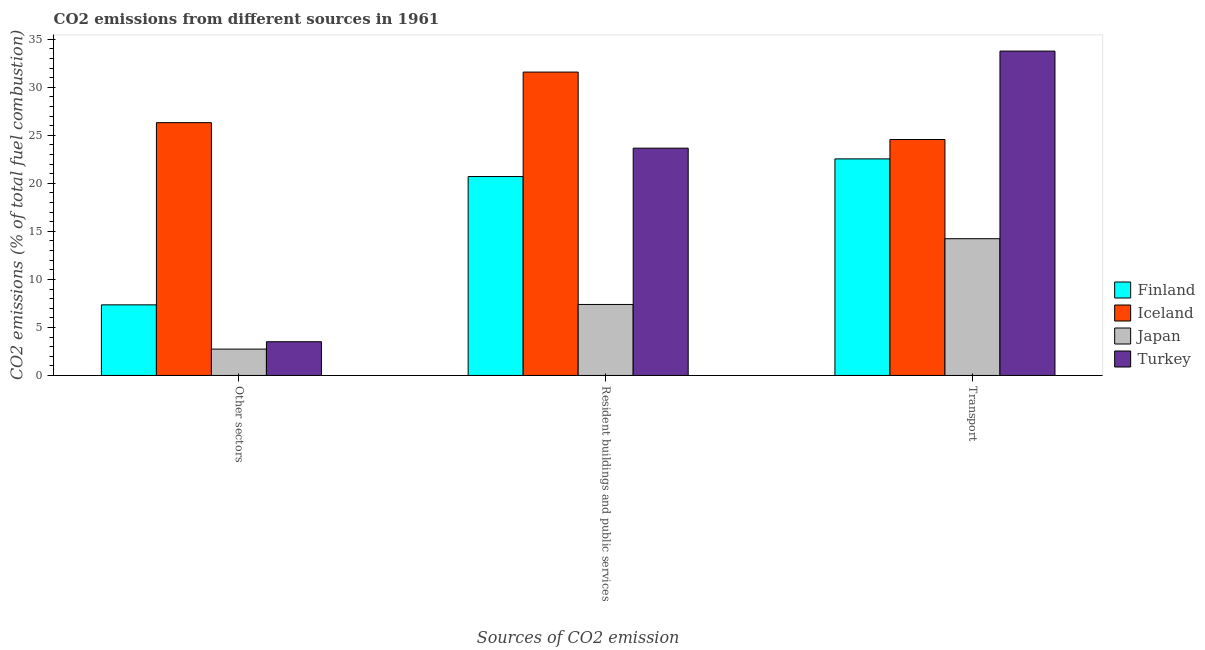How many different coloured bars are there?
Your answer should be very brief. 4. How many bars are there on the 1st tick from the left?
Ensure brevity in your answer.  4. What is the label of the 1st group of bars from the left?
Your answer should be very brief. Other sectors. What is the percentage of co2 emissions from resident buildings and public services in Iceland?
Your response must be concise. 31.58. Across all countries, what is the maximum percentage of co2 emissions from resident buildings and public services?
Keep it short and to the point. 31.58. Across all countries, what is the minimum percentage of co2 emissions from transport?
Your response must be concise. 14.23. In which country was the percentage of co2 emissions from transport minimum?
Keep it short and to the point. Japan. What is the total percentage of co2 emissions from resident buildings and public services in the graph?
Give a very brief answer. 83.34. What is the difference between the percentage of co2 emissions from other sectors in Finland and that in Japan?
Keep it short and to the point. 4.61. What is the difference between the percentage of co2 emissions from resident buildings and public services in Iceland and the percentage of co2 emissions from transport in Turkey?
Provide a short and direct response. -2.19. What is the average percentage of co2 emissions from transport per country?
Offer a terse response. 23.78. What is the difference between the percentage of co2 emissions from other sectors and percentage of co2 emissions from transport in Iceland?
Ensure brevity in your answer.  1.75. In how many countries, is the percentage of co2 emissions from other sectors greater than 20 %?
Provide a short and direct response. 1. What is the ratio of the percentage of co2 emissions from resident buildings and public services in Iceland to that in Japan?
Provide a short and direct response. 4.27. Is the percentage of co2 emissions from resident buildings and public services in Finland less than that in Turkey?
Your response must be concise. Yes. What is the difference between the highest and the second highest percentage of co2 emissions from transport?
Offer a very short reply. 9.2. What is the difference between the highest and the lowest percentage of co2 emissions from other sectors?
Your answer should be compact. 23.57. In how many countries, is the percentage of co2 emissions from resident buildings and public services greater than the average percentage of co2 emissions from resident buildings and public services taken over all countries?
Provide a short and direct response. 2. Is the sum of the percentage of co2 emissions from other sectors in Japan and Finland greater than the maximum percentage of co2 emissions from transport across all countries?
Offer a terse response. No. What does the 1st bar from the right in Transport represents?
Offer a very short reply. Turkey. How many bars are there?
Your answer should be compact. 12. Are all the bars in the graph horizontal?
Offer a terse response. No. Are the values on the major ticks of Y-axis written in scientific E-notation?
Your response must be concise. No. Does the graph contain any zero values?
Your answer should be very brief. No. How are the legend labels stacked?
Your response must be concise. Vertical. What is the title of the graph?
Your answer should be very brief. CO2 emissions from different sources in 1961. Does "El Salvador" appear as one of the legend labels in the graph?
Give a very brief answer. No. What is the label or title of the X-axis?
Make the answer very short. Sources of CO2 emission. What is the label or title of the Y-axis?
Make the answer very short. CO2 emissions (% of total fuel combustion). What is the CO2 emissions (% of total fuel combustion) in Finland in Other sectors?
Your response must be concise. 7.35. What is the CO2 emissions (% of total fuel combustion) in Iceland in Other sectors?
Offer a terse response. 26.32. What is the CO2 emissions (% of total fuel combustion) of Japan in Other sectors?
Make the answer very short. 2.74. What is the CO2 emissions (% of total fuel combustion) in Turkey in Other sectors?
Offer a very short reply. 3.51. What is the CO2 emissions (% of total fuel combustion) of Finland in Resident buildings and public services?
Offer a very short reply. 20.71. What is the CO2 emissions (% of total fuel combustion) in Iceland in Resident buildings and public services?
Your response must be concise. 31.58. What is the CO2 emissions (% of total fuel combustion) in Japan in Resident buildings and public services?
Ensure brevity in your answer.  7.39. What is the CO2 emissions (% of total fuel combustion) in Turkey in Resident buildings and public services?
Offer a terse response. 23.66. What is the CO2 emissions (% of total fuel combustion) of Finland in Transport?
Your answer should be very brief. 22.54. What is the CO2 emissions (% of total fuel combustion) of Iceland in Transport?
Ensure brevity in your answer.  24.56. What is the CO2 emissions (% of total fuel combustion) of Japan in Transport?
Keep it short and to the point. 14.23. What is the CO2 emissions (% of total fuel combustion) in Turkey in Transport?
Your answer should be very brief. 33.76. Across all Sources of CO2 emission, what is the maximum CO2 emissions (% of total fuel combustion) of Finland?
Ensure brevity in your answer.  22.54. Across all Sources of CO2 emission, what is the maximum CO2 emissions (% of total fuel combustion) of Iceland?
Offer a very short reply. 31.58. Across all Sources of CO2 emission, what is the maximum CO2 emissions (% of total fuel combustion) of Japan?
Provide a succinct answer. 14.23. Across all Sources of CO2 emission, what is the maximum CO2 emissions (% of total fuel combustion) of Turkey?
Make the answer very short. 33.76. Across all Sources of CO2 emission, what is the minimum CO2 emissions (% of total fuel combustion) in Finland?
Give a very brief answer. 7.35. Across all Sources of CO2 emission, what is the minimum CO2 emissions (% of total fuel combustion) of Iceland?
Ensure brevity in your answer.  24.56. Across all Sources of CO2 emission, what is the minimum CO2 emissions (% of total fuel combustion) of Japan?
Your response must be concise. 2.74. Across all Sources of CO2 emission, what is the minimum CO2 emissions (% of total fuel combustion) of Turkey?
Keep it short and to the point. 3.51. What is the total CO2 emissions (% of total fuel combustion) of Finland in the graph?
Offer a very short reply. 50.6. What is the total CO2 emissions (% of total fuel combustion) in Iceland in the graph?
Your response must be concise. 82.46. What is the total CO2 emissions (% of total fuel combustion) of Japan in the graph?
Make the answer very short. 24.37. What is the total CO2 emissions (% of total fuel combustion) in Turkey in the graph?
Give a very brief answer. 60.94. What is the difference between the CO2 emissions (% of total fuel combustion) in Finland in Other sectors and that in Resident buildings and public services?
Give a very brief answer. -13.36. What is the difference between the CO2 emissions (% of total fuel combustion) of Iceland in Other sectors and that in Resident buildings and public services?
Make the answer very short. -5.26. What is the difference between the CO2 emissions (% of total fuel combustion) of Japan in Other sectors and that in Resident buildings and public services?
Ensure brevity in your answer.  -4.65. What is the difference between the CO2 emissions (% of total fuel combustion) of Turkey in Other sectors and that in Resident buildings and public services?
Your response must be concise. -20.15. What is the difference between the CO2 emissions (% of total fuel combustion) of Finland in Other sectors and that in Transport?
Your response must be concise. -15.19. What is the difference between the CO2 emissions (% of total fuel combustion) of Iceland in Other sectors and that in Transport?
Offer a very short reply. 1.75. What is the difference between the CO2 emissions (% of total fuel combustion) in Japan in Other sectors and that in Transport?
Offer a very short reply. -11.49. What is the difference between the CO2 emissions (% of total fuel combustion) in Turkey in Other sectors and that in Transport?
Ensure brevity in your answer.  -30.25. What is the difference between the CO2 emissions (% of total fuel combustion) in Finland in Resident buildings and public services and that in Transport?
Your response must be concise. -1.84. What is the difference between the CO2 emissions (% of total fuel combustion) of Iceland in Resident buildings and public services and that in Transport?
Offer a very short reply. 7.02. What is the difference between the CO2 emissions (% of total fuel combustion) in Japan in Resident buildings and public services and that in Transport?
Keep it short and to the point. -6.84. What is the difference between the CO2 emissions (% of total fuel combustion) of Turkey in Resident buildings and public services and that in Transport?
Keep it short and to the point. -10.1. What is the difference between the CO2 emissions (% of total fuel combustion) of Finland in Other sectors and the CO2 emissions (% of total fuel combustion) of Iceland in Resident buildings and public services?
Your answer should be very brief. -24.23. What is the difference between the CO2 emissions (% of total fuel combustion) in Finland in Other sectors and the CO2 emissions (% of total fuel combustion) in Japan in Resident buildings and public services?
Keep it short and to the point. -0.04. What is the difference between the CO2 emissions (% of total fuel combustion) in Finland in Other sectors and the CO2 emissions (% of total fuel combustion) in Turkey in Resident buildings and public services?
Your answer should be very brief. -16.31. What is the difference between the CO2 emissions (% of total fuel combustion) of Iceland in Other sectors and the CO2 emissions (% of total fuel combustion) of Japan in Resident buildings and public services?
Your answer should be compact. 18.93. What is the difference between the CO2 emissions (% of total fuel combustion) in Iceland in Other sectors and the CO2 emissions (% of total fuel combustion) in Turkey in Resident buildings and public services?
Your response must be concise. 2.66. What is the difference between the CO2 emissions (% of total fuel combustion) in Japan in Other sectors and the CO2 emissions (% of total fuel combustion) in Turkey in Resident buildings and public services?
Keep it short and to the point. -20.92. What is the difference between the CO2 emissions (% of total fuel combustion) of Finland in Other sectors and the CO2 emissions (% of total fuel combustion) of Iceland in Transport?
Your response must be concise. -17.21. What is the difference between the CO2 emissions (% of total fuel combustion) of Finland in Other sectors and the CO2 emissions (% of total fuel combustion) of Japan in Transport?
Make the answer very short. -6.88. What is the difference between the CO2 emissions (% of total fuel combustion) in Finland in Other sectors and the CO2 emissions (% of total fuel combustion) in Turkey in Transport?
Provide a short and direct response. -26.41. What is the difference between the CO2 emissions (% of total fuel combustion) in Iceland in Other sectors and the CO2 emissions (% of total fuel combustion) in Japan in Transport?
Give a very brief answer. 12.08. What is the difference between the CO2 emissions (% of total fuel combustion) in Iceland in Other sectors and the CO2 emissions (% of total fuel combustion) in Turkey in Transport?
Ensure brevity in your answer.  -7.45. What is the difference between the CO2 emissions (% of total fuel combustion) in Japan in Other sectors and the CO2 emissions (% of total fuel combustion) in Turkey in Transport?
Give a very brief answer. -31.02. What is the difference between the CO2 emissions (% of total fuel combustion) in Finland in Resident buildings and public services and the CO2 emissions (% of total fuel combustion) in Iceland in Transport?
Offer a very short reply. -3.85. What is the difference between the CO2 emissions (% of total fuel combustion) in Finland in Resident buildings and public services and the CO2 emissions (% of total fuel combustion) in Japan in Transport?
Offer a very short reply. 6.47. What is the difference between the CO2 emissions (% of total fuel combustion) of Finland in Resident buildings and public services and the CO2 emissions (% of total fuel combustion) of Turkey in Transport?
Your answer should be very brief. -13.06. What is the difference between the CO2 emissions (% of total fuel combustion) of Iceland in Resident buildings and public services and the CO2 emissions (% of total fuel combustion) of Japan in Transport?
Keep it short and to the point. 17.34. What is the difference between the CO2 emissions (% of total fuel combustion) in Iceland in Resident buildings and public services and the CO2 emissions (% of total fuel combustion) in Turkey in Transport?
Your answer should be very brief. -2.19. What is the difference between the CO2 emissions (% of total fuel combustion) of Japan in Resident buildings and public services and the CO2 emissions (% of total fuel combustion) of Turkey in Transport?
Give a very brief answer. -26.37. What is the average CO2 emissions (% of total fuel combustion) in Finland per Sources of CO2 emission?
Your answer should be compact. 16.87. What is the average CO2 emissions (% of total fuel combustion) of Iceland per Sources of CO2 emission?
Ensure brevity in your answer.  27.49. What is the average CO2 emissions (% of total fuel combustion) of Japan per Sources of CO2 emission?
Keep it short and to the point. 8.12. What is the average CO2 emissions (% of total fuel combustion) in Turkey per Sources of CO2 emission?
Offer a terse response. 20.31. What is the difference between the CO2 emissions (% of total fuel combustion) in Finland and CO2 emissions (% of total fuel combustion) in Iceland in Other sectors?
Your response must be concise. -18.97. What is the difference between the CO2 emissions (% of total fuel combustion) of Finland and CO2 emissions (% of total fuel combustion) of Japan in Other sectors?
Your answer should be very brief. 4.61. What is the difference between the CO2 emissions (% of total fuel combustion) in Finland and CO2 emissions (% of total fuel combustion) in Turkey in Other sectors?
Your response must be concise. 3.84. What is the difference between the CO2 emissions (% of total fuel combustion) in Iceland and CO2 emissions (% of total fuel combustion) in Japan in Other sectors?
Offer a terse response. 23.57. What is the difference between the CO2 emissions (% of total fuel combustion) in Iceland and CO2 emissions (% of total fuel combustion) in Turkey in Other sectors?
Ensure brevity in your answer.  22.8. What is the difference between the CO2 emissions (% of total fuel combustion) in Japan and CO2 emissions (% of total fuel combustion) in Turkey in Other sectors?
Provide a succinct answer. -0.77. What is the difference between the CO2 emissions (% of total fuel combustion) in Finland and CO2 emissions (% of total fuel combustion) in Iceland in Resident buildings and public services?
Your answer should be compact. -10.87. What is the difference between the CO2 emissions (% of total fuel combustion) of Finland and CO2 emissions (% of total fuel combustion) of Japan in Resident buildings and public services?
Offer a very short reply. 13.32. What is the difference between the CO2 emissions (% of total fuel combustion) in Finland and CO2 emissions (% of total fuel combustion) in Turkey in Resident buildings and public services?
Your answer should be compact. -2.95. What is the difference between the CO2 emissions (% of total fuel combustion) in Iceland and CO2 emissions (% of total fuel combustion) in Japan in Resident buildings and public services?
Make the answer very short. 24.19. What is the difference between the CO2 emissions (% of total fuel combustion) of Iceland and CO2 emissions (% of total fuel combustion) of Turkey in Resident buildings and public services?
Provide a short and direct response. 7.92. What is the difference between the CO2 emissions (% of total fuel combustion) in Japan and CO2 emissions (% of total fuel combustion) in Turkey in Resident buildings and public services?
Ensure brevity in your answer.  -16.27. What is the difference between the CO2 emissions (% of total fuel combustion) in Finland and CO2 emissions (% of total fuel combustion) in Iceland in Transport?
Give a very brief answer. -2.02. What is the difference between the CO2 emissions (% of total fuel combustion) of Finland and CO2 emissions (% of total fuel combustion) of Japan in Transport?
Offer a terse response. 8.31. What is the difference between the CO2 emissions (% of total fuel combustion) of Finland and CO2 emissions (% of total fuel combustion) of Turkey in Transport?
Ensure brevity in your answer.  -11.22. What is the difference between the CO2 emissions (% of total fuel combustion) in Iceland and CO2 emissions (% of total fuel combustion) in Japan in Transport?
Give a very brief answer. 10.33. What is the difference between the CO2 emissions (% of total fuel combustion) of Iceland and CO2 emissions (% of total fuel combustion) of Turkey in Transport?
Offer a terse response. -9.2. What is the difference between the CO2 emissions (% of total fuel combustion) in Japan and CO2 emissions (% of total fuel combustion) in Turkey in Transport?
Make the answer very short. -19.53. What is the ratio of the CO2 emissions (% of total fuel combustion) of Finland in Other sectors to that in Resident buildings and public services?
Make the answer very short. 0.35. What is the ratio of the CO2 emissions (% of total fuel combustion) in Japan in Other sectors to that in Resident buildings and public services?
Offer a terse response. 0.37. What is the ratio of the CO2 emissions (% of total fuel combustion) of Turkey in Other sectors to that in Resident buildings and public services?
Provide a succinct answer. 0.15. What is the ratio of the CO2 emissions (% of total fuel combustion) of Finland in Other sectors to that in Transport?
Your response must be concise. 0.33. What is the ratio of the CO2 emissions (% of total fuel combustion) of Iceland in Other sectors to that in Transport?
Offer a very short reply. 1.07. What is the ratio of the CO2 emissions (% of total fuel combustion) in Japan in Other sectors to that in Transport?
Make the answer very short. 0.19. What is the ratio of the CO2 emissions (% of total fuel combustion) in Turkey in Other sectors to that in Transport?
Keep it short and to the point. 0.1. What is the ratio of the CO2 emissions (% of total fuel combustion) of Finland in Resident buildings and public services to that in Transport?
Provide a short and direct response. 0.92. What is the ratio of the CO2 emissions (% of total fuel combustion) of Japan in Resident buildings and public services to that in Transport?
Make the answer very short. 0.52. What is the ratio of the CO2 emissions (% of total fuel combustion) of Turkey in Resident buildings and public services to that in Transport?
Your response must be concise. 0.7. What is the difference between the highest and the second highest CO2 emissions (% of total fuel combustion) in Finland?
Your answer should be compact. 1.84. What is the difference between the highest and the second highest CO2 emissions (% of total fuel combustion) of Iceland?
Provide a succinct answer. 5.26. What is the difference between the highest and the second highest CO2 emissions (% of total fuel combustion) of Japan?
Give a very brief answer. 6.84. What is the difference between the highest and the second highest CO2 emissions (% of total fuel combustion) of Turkey?
Offer a terse response. 10.1. What is the difference between the highest and the lowest CO2 emissions (% of total fuel combustion) in Finland?
Make the answer very short. 15.19. What is the difference between the highest and the lowest CO2 emissions (% of total fuel combustion) of Iceland?
Your response must be concise. 7.02. What is the difference between the highest and the lowest CO2 emissions (% of total fuel combustion) in Japan?
Keep it short and to the point. 11.49. What is the difference between the highest and the lowest CO2 emissions (% of total fuel combustion) of Turkey?
Keep it short and to the point. 30.25. 